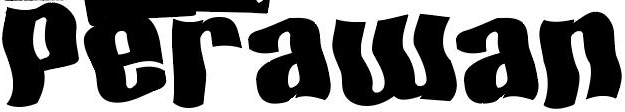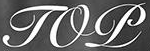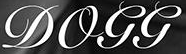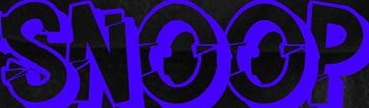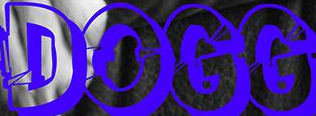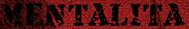Read the text content from these images in order, separated by a semicolon. Perawan; TOP; DOGG; SNOOP; DOGG; MENTALITA 